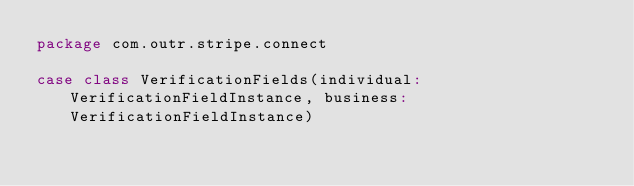Convert code to text. <code><loc_0><loc_0><loc_500><loc_500><_Scala_>package com.outr.stripe.connect

case class VerificationFields(individual: VerificationFieldInstance, business: VerificationFieldInstance)
</code> 